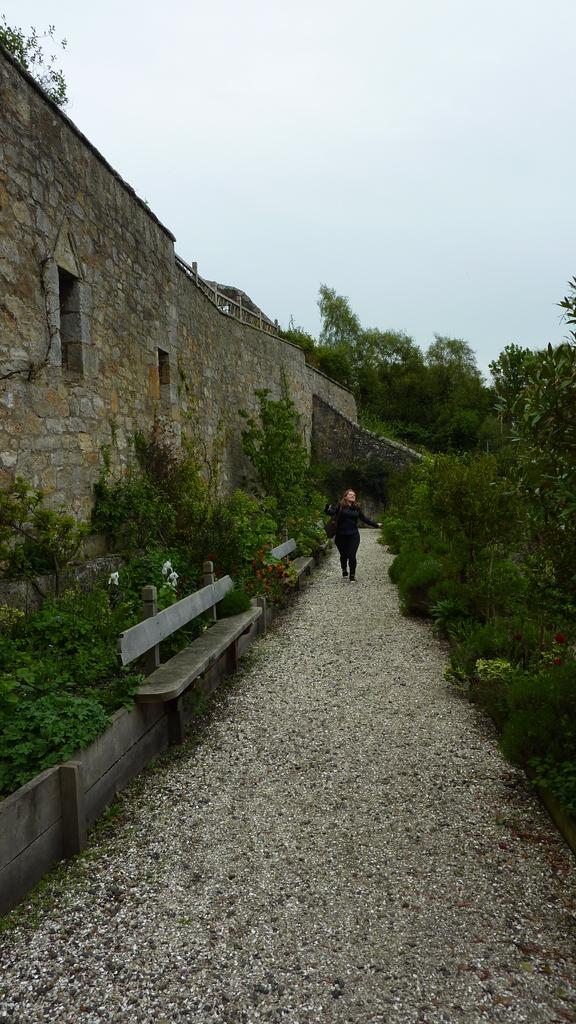What is the main structure visible in the image? There is a long wall in the image. What is in front of the wall? There are plants in front of the wall. What type of seating is available in the image? There are two benches beside the plants. Where is the woman located in the image? There is a woman in between the path of trees and the wall. How many ants can be seen carrying leaves on the wall in the image? There are no ants visible in the image, and they are not carrying leaves on the wall. What type of disease is affecting the plants in the image? There is no indication of any disease affecting the plants in the image. 